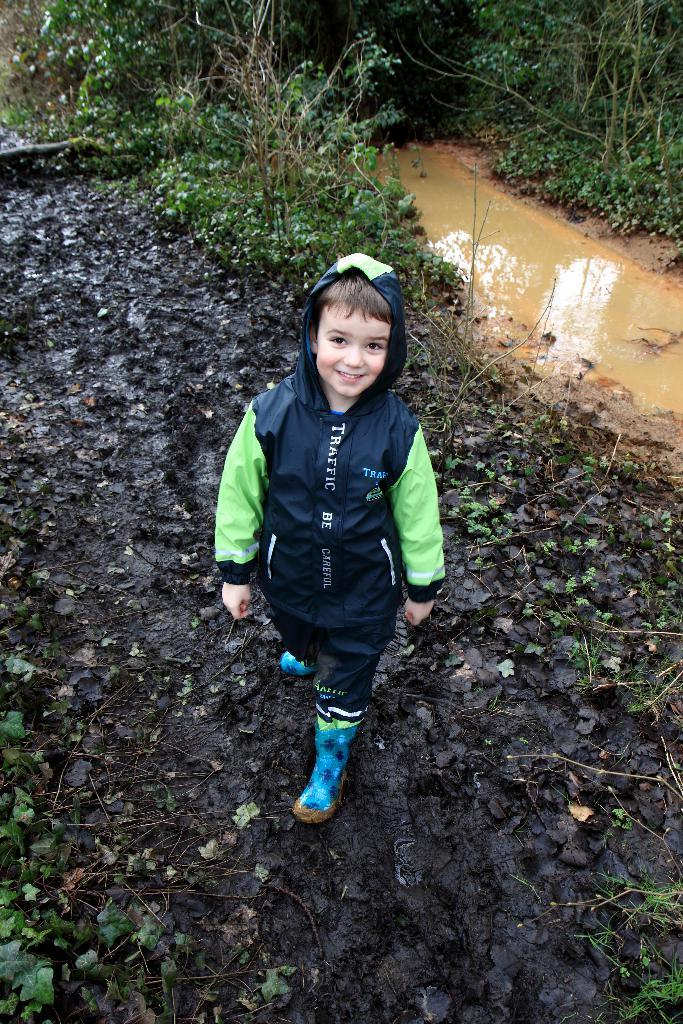Who is the main subject in the image? There is a boy in the image. What is the boy doing in the image? The boy is standing on a path. What can be seen in the background of the image? There are plants and water visible in the background of the image. Are there any giants visible in the image? No, there are no giants present in the image. Can you see any goldfish or jellyfish in the water in the background of the image? No, there are no goldfish or jellyfish visible in the water in the background of the image. 